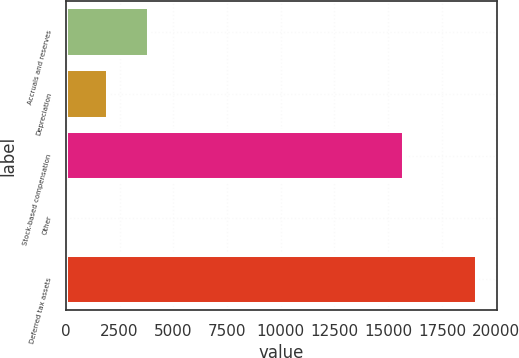Convert chart to OTSL. <chart><loc_0><loc_0><loc_500><loc_500><bar_chart><fcel>Accruals and reserves<fcel>Depreciation<fcel>Stock-based compensation<fcel>Other<fcel>Deferred tax assets<nl><fcel>3884.6<fcel>1980.3<fcel>15736<fcel>76<fcel>19119<nl></chart> 